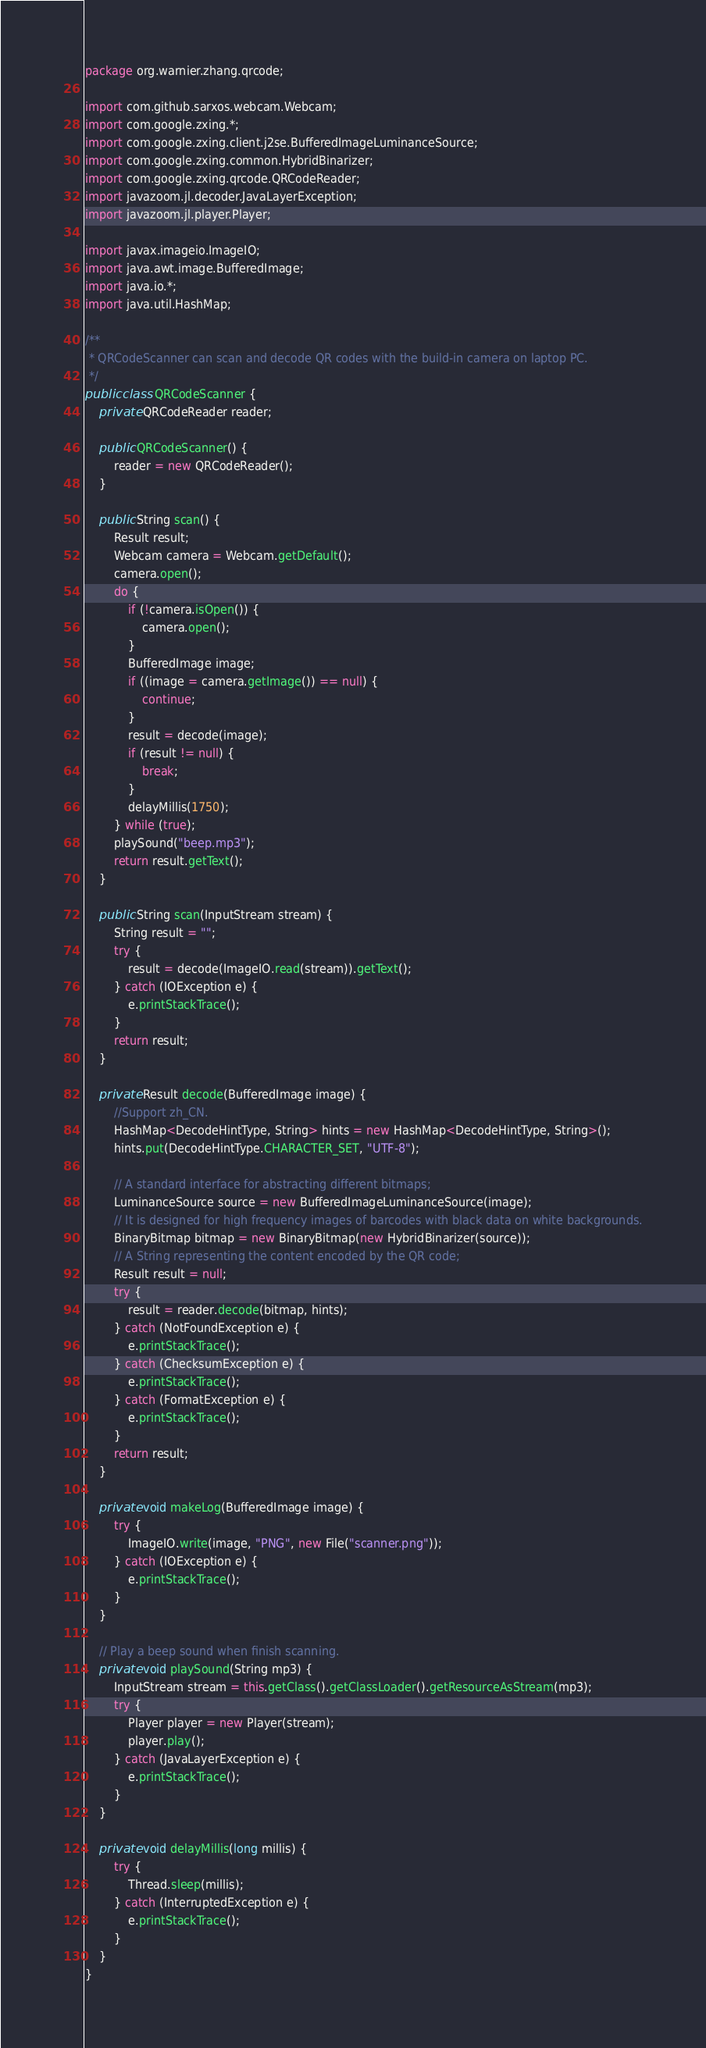<code> <loc_0><loc_0><loc_500><loc_500><_Java_>package org.warnier.zhang.qrcode;

import com.github.sarxos.webcam.Webcam;
import com.google.zxing.*;
import com.google.zxing.client.j2se.BufferedImageLuminanceSource;
import com.google.zxing.common.HybridBinarizer;
import com.google.zxing.qrcode.QRCodeReader;
import javazoom.jl.decoder.JavaLayerException;
import javazoom.jl.player.Player;

import javax.imageio.ImageIO;
import java.awt.image.BufferedImage;
import java.io.*;
import java.util.HashMap;

/**
 * QRCodeScanner can scan and decode QR codes with the build-in camera on laptop PC.
 */
public class QRCodeScanner {
    private QRCodeReader reader;

    public QRCodeScanner() {
        reader = new QRCodeReader();
    }

    public String scan() {
        Result result;
        Webcam camera = Webcam.getDefault();
        camera.open();
        do {
            if (!camera.isOpen()) {
                camera.open();
            }
            BufferedImage image;
            if ((image = camera.getImage()) == null) {
                continue;
            }
            result = decode(image);
            if (result != null) {
                break;
            }
            delayMillis(1750);
        } while (true);
        playSound("beep.mp3");
        return result.getText();
    }

    public String scan(InputStream stream) {
        String result = "";
        try {
            result = decode(ImageIO.read(stream)).getText();
        } catch (IOException e) {
            e.printStackTrace();
        }
        return result;
    }

    private Result decode(BufferedImage image) {
        //Support zh_CN.
        HashMap<DecodeHintType, String> hints = new HashMap<DecodeHintType, String>();
        hints.put(DecodeHintType.CHARACTER_SET, "UTF-8");

        // A standard interface for abstracting different bitmaps;
        LuminanceSource source = new BufferedImageLuminanceSource(image);
        // It is designed for high frequency images of barcodes with black data on white backgrounds.
        BinaryBitmap bitmap = new BinaryBitmap(new HybridBinarizer(source));
        // A String representing the content encoded by the QR code;
        Result result = null;
        try {
            result = reader.decode(bitmap, hints);
        } catch (NotFoundException e) {
            e.printStackTrace();
        } catch (ChecksumException e) {
            e.printStackTrace();
        } catch (FormatException e) {
            e.printStackTrace();
        }
        return result;
    }

    private void makeLog(BufferedImage image) {
        try {
            ImageIO.write(image, "PNG", new File("scanner.png"));
        } catch (IOException e) {
            e.printStackTrace();
        }
    }

    // Play a beep sound when finish scanning.
    private void playSound(String mp3) {
        InputStream stream = this.getClass().getClassLoader().getResourceAsStream(mp3);
        try {
            Player player = new Player(stream);
            player.play();
        } catch (JavaLayerException e) {
            e.printStackTrace();
        }
    }

    private void delayMillis(long millis) {
        try {
            Thread.sleep(millis);
        } catch (InterruptedException e) {
            e.printStackTrace();
        }
    }
}
</code> 